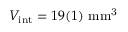Convert formula to latex. <formula><loc_0><loc_0><loc_500><loc_500>V _ { i n t } = 1 9 ( 1 ) m m ^ { 3 }</formula> 